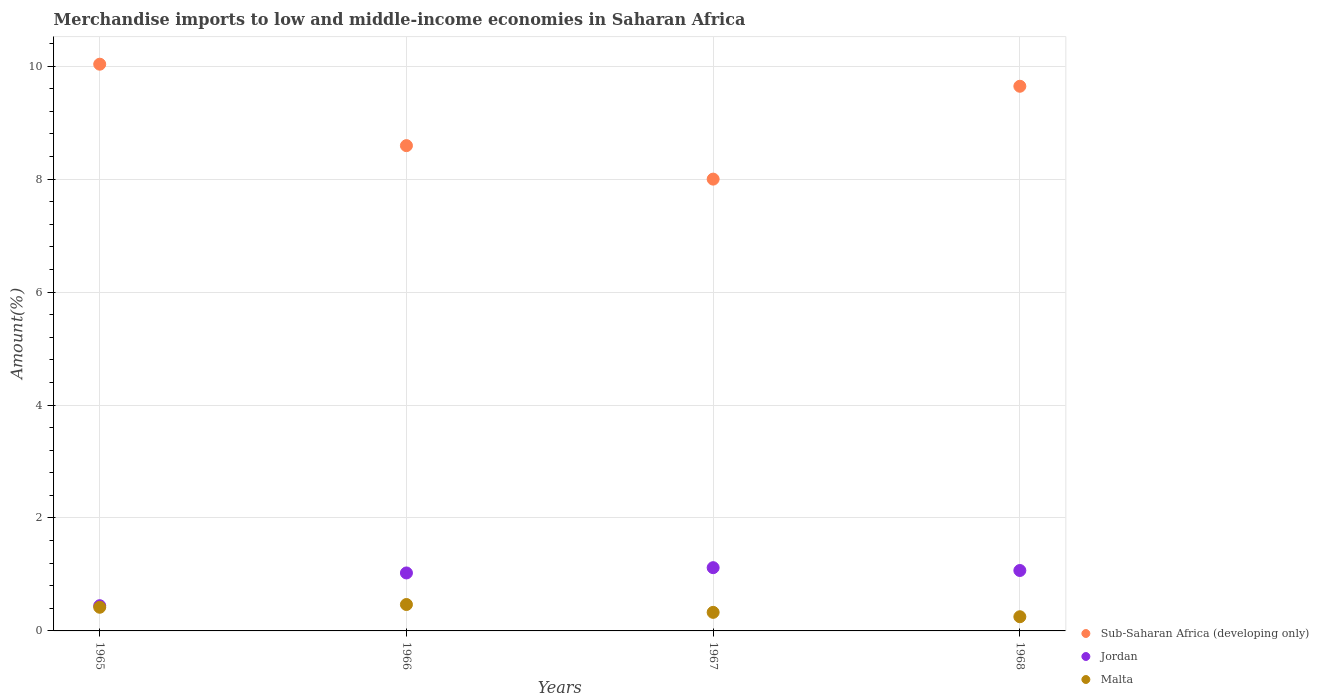What is the percentage of amount earned from merchandise imports in Sub-Saharan Africa (developing only) in 1965?
Offer a terse response. 10.03. Across all years, what is the maximum percentage of amount earned from merchandise imports in Malta?
Your answer should be very brief. 0.47. Across all years, what is the minimum percentage of amount earned from merchandise imports in Jordan?
Offer a very short reply. 0.45. In which year was the percentage of amount earned from merchandise imports in Malta maximum?
Provide a short and direct response. 1966. In which year was the percentage of amount earned from merchandise imports in Sub-Saharan Africa (developing only) minimum?
Your answer should be compact. 1967. What is the total percentage of amount earned from merchandise imports in Malta in the graph?
Give a very brief answer. 1.47. What is the difference between the percentage of amount earned from merchandise imports in Sub-Saharan Africa (developing only) in 1965 and that in 1966?
Offer a very short reply. 1.44. What is the difference between the percentage of amount earned from merchandise imports in Malta in 1968 and the percentage of amount earned from merchandise imports in Sub-Saharan Africa (developing only) in 1965?
Ensure brevity in your answer.  -9.78. What is the average percentage of amount earned from merchandise imports in Sub-Saharan Africa (developing only) per year?
Provide a short and direct response. 9.07. In the year 1965, what is the difference between the percentage of amount earned from merchandise imports in Jordan and percentage of amount earned from merchandise imports in Sub-Saharan Africa (developing only)?
Your response must be concise. -9.59. In how many years, is the percentage of amount earned from merchandise imports in Sub-Saharan Africa (developing only) greater than 7.2 %?
Ensure brevity in your answer.  4. What is the ratio of the percentage of amount earned from merchandise imports in Malta in 1966 to that in 1968?
Offer a terse response. 1.86. Is the difference between the percentage of amount earned from merchandise imports in Jordan in 1967 and 1968 greater than the difference between the percentage of amount earned from merchandise imports in Sub-Saharan Africa (developing only) in 1967 and 1968?
Make the answer very short. Yes. What is the difference between the highest and the second highest percentage of amount earned from merchandise imports in Jordan?
Make the answer very short. 0.05. What is the difference between the highest and the lowest percentage of amount earned from merchandise imports in Malta?
Your answer should be compact. 0.22. In how many years, is the percentage of amount earned from merchandise imports in Jordan greater than the average percentage of amount earned from merchandise imports in Jordan taken over all years?
Provide a short and direct response. 3. Is the sum of the percentage of amount earned from merchandise imports in Jordan in 1965 and 1968 greater than the maximum percentage of amount earned from merchandise imports in Sub-Saharan Africa (developing only) across all years?
Your response must be concise. No. Is the percentage of amount earned from merchandise imports in Sub-Saharan Africa (developing only) strictly greater than the percentage of amount earned from merchandise imports in Malta over the years?
Your response must be concise. Yes. Is the percentage of amount earned from merchandise imports in Jordan strictly less than the percentage of amount earned from merchandise imports in Malta over the years?
Provide a short and direct response. No. What is the difference between two consecutive major ticks on the Y-axis?
Your answer should be compact. 2. Are the values on the major ticks of Y-axis written in scientific E-notation?
Your response must be concise. No. Does the graph contain any zero values?
Provide a succinct answer. No. Does the graph contain grids?
Provide a succinct answer. Yes. Where does the legend appear in the graph?
Your answer should be very brief. Bottom right. How many legend labels are there?
Your response must be concise. 3. How are the legend labels stacked?
Your response must be concise. Vertical. What is the title of the graph?
Provide a short and direct response. Merchandise imports to low and middle-income economies in Saharan Africa. What is the label or title of the Y-axis?
Offer a terse response. Amount(%). What is the Amount(%) in Sub-Saharan Africa (developing only) in 1965?
Keep it short and to the point. 10.03. What is the Amount(%) in Jordan in 1965?
Offer a terse response. 0.45. What is the Amount(%) of Malta in 1965?
Offer a terse response. 0.42. What is the Amount(%) in Sub-Saharan Africa (developing only) in 1966?
Ensure brevity in your answer.  8.59. What is the Amount(%) in Jordan in 1966?
Make the answer very short. 1.03. What is the Amount(%) in Malta in 1966?
Give a very brief answer. 0.47. What is the Amount(%) in Sub-Saharan Africa (developing only) in 1967?
Keep it short and to the point. 8. What is the Amount(%) of Jordan in 1967?
Your response must be concise. 1.12. What is the Amount(%) in Malta in 1967?
Your response must be concise. 0.33. What is the Amount(%) in Sub-Saharan Africa (developing only) in 1968?
Make the answer very short. 9.64. What is the Amount(%) in Jordan in 1968?
Provide a succinct answer. 1.07. What is the Amount(%) of Malta in 1968?
Offer a terse response. 0.25. Across all years, what is the maximum Amount(%) in Sub-Saharan Africa (developing only)?
Offer a very short reply. 10.03. Across all years, what is the maximum Amount(%) in Jordan?
Make the answer very short. 1.12. Across all years, what is the maximum Amount(%) in Malta?
Offer a very short reply. 0.47. Across all years, what is the minimum Amount(%) in Sub-Saharan Africa (developing only)?
Your answer should be compact. 8. Across all years, what is the minimum Amount(%) in Jordan?
Offer a very short reply. 0.45. Across all years, what is the minimum Amount(%) in Malta?
Offer a very short reply. 0.25. What is the total Amount(%) in Sub-Saharan Africa (developing only) in the graph?
Provide a succinct answer. 36.27. What is the total Amount(%) of Jordan in the graph?
Your response must be concise. 3.66. What is the total Amount(%) in Malta in the graph?
Offer a very short reply. 1.47. What is the difference between the Amount(%) of Sub-Saharan Africa (developing only) in 1965 and that in 1966?
Ensure brevity in your answer.  1.44. What is the difference between the Amount(%) in Jordan in 1965 and that in 1966?
Your answer should be compact. -0.58. What is the difference between the Amount(%) of Malta in 1965 and that in 1966?
Your response must be concise. -0.05. What is the difference between the Amount(%) in Sub-Saharan Africa (developing only) in 1965 and that in 1967?
Keep it short and to the point. 2.03. What is the difference between the Amount(%) in Jordan in 1965 and that in 1967?
Your answer should be compact. -0.67. What is the difference between the Amount(%) of Malta in 1965 and that in 1967?
Make the answer very short. 0.09. What is the difference between the Amount(%) of Sub-Saharan Africa (developing only) in 1965 and that in 1968?
Offer a very short reply. 0.39. What is the difference between the Amount(%) of Jordan in 1965 and that in 1968?
Make the answer very short. -0.62. What is the difference between the Amount(%) in Malta in 1965 and that in 1968?
Make the answer very short. 0.17. What is the difference between the Amount(%) in Sub-Saharan Africa (developing only) in 1966 and that in 1967?
Your answer should be compact. 0.59. What is the difference between the Amount(%) in Jordan in 1966 and that in 1967?
Offer a terse response. -0.09. What is the difference between the Amount(%) of Malta in 1966 and that in 1967?
Make the answer very short. 0.14. What is the difference between the Amount(%) of Sub-Saharan Africa (developing only) in 1966 and that in 1968?
Ensure brevity in your answer.  -1.05. What is the difference between the Amount(%) in Jordan in 1966 and that in 1968?
Give a very brief answer. -0.04. What is the difference between the Amount(%) of Malta in 1966 and that in 1968?
Ensure brevity in your answer.  0.22. What is the difference between the Amount(%) in Sub-Saharan Africa (developing only) in 1967 and that in 1968?
Ensure brevity in your answer.  -1.64. What is the difference between the Amount(%) of Jordan in 1967 and that in 1968?
Your answer should be compact. 0.05. What is the difference between the Amount(%) in Malta in 1967 and that in 1968?
Provide a short and direct response. 0.08. What is the difference between the Amount(%) in Sub-Saharan Africa (developing only) in 1965 and the Amount(%) in Jordan in 1966?
Offer a terse response. 9.01. What is the difference between the Amount(%) of Sub-Saharan Africa (developing only) in 1965 and the Amount(%) of Malta in 1966?
Keep it short and to the point. 9.57. What is the difference between the Amount(%) in Jordan in 1965 and the Amount(%) in Malta in 1966?
Your answer should be compact. -0.02. What is the difference between the Amount(%) in Sub-Saharan Africa (developing only) in 1965 and the Amount(%) in Jordan in 1967?
Give a very brief answer. 8.91. What is the difference between the Amount(%) of Sub-Saharan Africa (developing only) in 1965 and the Amount(%) of Malta in 1967?
Provide a short and direct response. 9.71. What is the difference between the Amount(%) of Jordan in 1965 and the Amount(%) of Malta in 1967?
Your answer should be compact. 0.12. What is the difference between the Amount(%) of Sub-Saharan Africa (developing only) in 1965 and the Amount(%) of Jordan in 1968?
Keep it short and to the point. 8.96. What is the difference between the Amount(%) in Sub-Saharan Africa (developing only) in 1965 and the Amount(%) in Malta in 1968?
Give a very brief answer. 9.78. What is the difference between the Amount(%) of Jordan in 1965 and the Amount(%) of Malta in 1968?
Your response must be concise. 0.2. What is the difference between the Amount(%) of Sub-Saharan Africa (developing only) in 1966 and the Amount(%) of Jordan in 1967?
Make the answer very short. 7.47. What is the difference between the Amount(%) of Sub-Saharan Africa (developing only) in 1966 and the Amount(%) of Malta in 1967?
Give a very brief answer. 8.26. What is the difference between the Amount(%) in Jordan in 1966 and the Amount(%) in Malta in 1967?
Your answer should be compact. 0.7. What is the difference between the Amount(%) in Sub-Saharan Africa (developing only) in 1966 and the Amount(%) in Jordan in 1968?
Your answer should be very brief. 7.52. What is the difference between the Amount(%) in Sub-Saharan Africa (developing only) in 1966 and the Amount(%) in Malta in 1968?
Ensure brevity in your answer.  8.34. What is the difference between the Amount(%) in Jordan in 1966 and the Amount(%) in Malta in 1968?
Your answer should be compact. 0.78. What is the difference between the Amount(%) of Sub-Saharan Africa (developing only) in 1967 and the Amount(%) of Jordan in 1968?
Offer a very short reply. 6.93. What is the difference between the Amount(%) in Sub-Saharan Africa (developing only) in 1967 and the Amount(%) in Malta in 1968?
Provide a succinct answer. 7.75. What is the difference between the Amount(%) of Jordan in 1967 and the Amount(%) of Malta in 1968?
Provide a short and direct response. 0.87. What is the average Amount(%) of Sub-Saharan Africa (developing only) per year?
Make the answer very short. 9.07. What is the average Amount(%) in Jordan per year?
Offer a terse response. 0.92. What is the average Amount(%) in Malta per year?
Offer a very short reply. 0.37. In the year 1965, what is the difference between the Amount(%) in Sub-Saharan Africa (developing only) and Amount(%) in Jordan?
Provide a succinct answer. 9.59. In the year 1965, what is the difference between the Amount(%) in Sub-Saharan Africa (developing only) and Amount(%) in Malta?
Offer a very short reply. 9.62. In the year 1965, what is the difference between the Amount(%) in Jordan and Amount(%) in Malta?
Keep it short and to the point. 0.03. In the year 1966, what is the difference between the Amount(%) of Sub-Saharan Africa (developing only) and Amount(%) of Jordan?
Offer a terse response. 7.57. In the year 1966, what is the difference between the Amount(%) of Sub-Saharan Africa (developing only) and Amount(%) of Malta?
Provide a succinct answer. 8.12. In the year 1966, what is the difference between the Amount(%) of Jordan and Amount(%) of Malta?
Make the answer very short. 0.56. In the year 1967, what is the difference between the Amount(%) of Sub-Saharan Africa (developing only) and Amount(%) of Jordan?
Make the answer very short. 6.88. In the year 1967, what is the difference between the Amount(%) in Sub-Saharan Africa (developing only) and Amount(%) in Malta?
Provide a short and direct response. 7.67. In the year 1967, what is the difference between the Amount(%) of Jordan and Amount(%) of Malta?
Make the answer very short. 0.79. In the year 1968, what is the difference between the Amount(%) of Sub-Saharan Africa (developing only) and Amount(%) of Jordan?
Provide a short and direct response. 8.57. In the year 1968, what is the difference between the Amount(%) of Sub-Saharan Africa (developing only) and Amount(%) of Malta?
Provide a succinct answer. 9.39. In the year 1968, what is the difference between the Amount(%) in Jordan and Amount(%) in Malta?
Provide a short and direct response. 0.82. What is the ratio of the Amount(%) in Sub-Saharan Africa (developing only) in 1965 to that in 1966?
Make the answer very short. 1.17. What is the ratio of the Amount(%) in Jordan in 1965 to that in 1966?
Give a very brief answer. 0.43. What is the ratio of the Amount(%) in Malta in 1965 to that in 1966?
Provide a succinct answer. 0.9. What is the ratio of the Amount(%) in Sub-Saharan Africa (developing only) in 1965 to that in 1967?
Provide a succinct answer. 1.25. What is the ratio of the Amount(%) of Jordan in 1965 to that in 1967?
Give a very brief answer. 0.4. What is the ratio of the Amount(%) of Malta in 1965 to that in 1967?
Offer a very short reply. 1.27. What is the ratio of the Amount(%) of Sub-Saharan Africa (developing only) in 1965 to that in 1968?
Your answer should be compact. 1.04. What is the ratio of the Amount(%) in Jordan in 1965 to that in 1968?
Keep it short and to the point. 0.42. What is the ratio of the Amount(%) of Malta in 1965 to that in 1968?
Give a very brief answer. 1.67. What is the ratio of the Amount(%) of Sub-Saharan Africa (developing only) in 1966 to that in 1967?
Provide a succinct answer. 1.07. What is the ratio of the Amount(%) in Jordan in 1966 to that in 1967?
Your response must be concise. 0.92. What is the ratio of the Amount(%) in Malta in 1966 to that in 1967?
Offer a terse response. 1.42. What is the ratio of the Amount(%) of Sub-Saharan Africa (developing only) in 1966 to that in 1968?
Ensure brevity in your answer.  0.89. What is the ratio of the Amount(%) of Jordan in 1966 to that in 1968?
Make the answer very short. 0.96. What is the ratio of the Amount(%) in Malta in 1966 to that in 1968?
Offer a very short reply. 1.86. What is the ratio of the Amount(%) in Sub-Saharan Africa (developing only) in 1967 to that in 1968?
Provide a short and direct response. 0.83. What is the ratio of the Amount(%) in Jordan in 1967 to that in 1968?
Provide a short and direct response. 1.05. What is the ratio of the Amount(%) in Malta in 1967 to that in 1968?
Your answer should be very brief. 1.31. What is the difference between the highest and the second highest Amount(%) in Sub-Saharan Africa (developing only)?
Your answer should be very brief. 0.39. What is the difference between the highest and the second highest Amount(%) in Malta?
Your answer should be compact. 0.05. What is the difference between the highest and the lowest Amount(%) of Sub-Saharan Africa (developing only)?
Your response must be concise. 2.03. What is the difference between the highest and the lowest Amount(%) in Jordan?
Make the answer very short. 0.67. What is the difference between the highest and the lowest Amount(%) in Malta?
Provide a succinct answer. 0.22. 